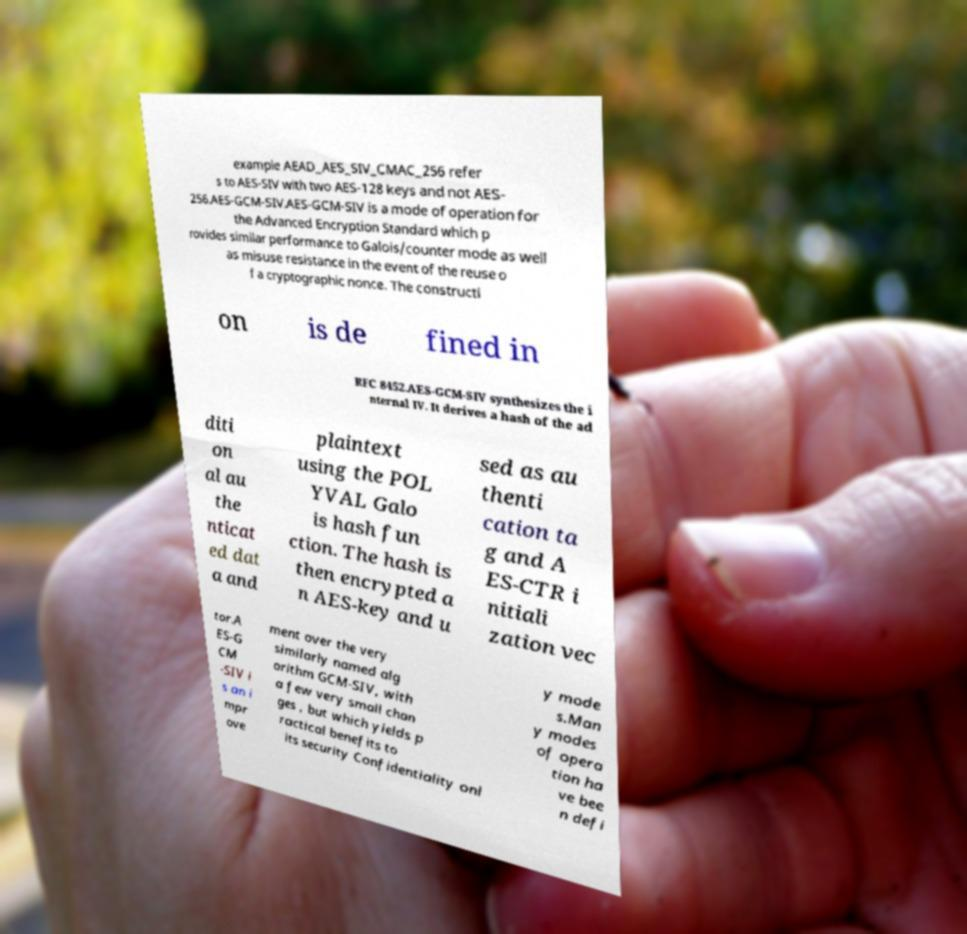Can you read and provide the text displayed in the image?This photo seems to have some interesting text. Can you extract and type it out for me? example AEAD_AES_SIV_CMAC_256 refer s to AES-SIV with two AES-128 keys and not AES- 256.AES-GCM-SIV.AES-GCM-SIV is a mode of operation for the Advanced Encryption Standard which p rovides similar performance to Galois/counter mode as well as misuse resistance in the event of the reuse o f a cryptographic nonce. The constructi on is de fined in RFC 8452.AES-GCM-SIV synthesizes the i nternal IV. It derives a hash of the ad diti on al au the nticat ed dat a and plaintext using the POL YVAL Galo is hash fun ction. The hash is then encrypted a n AES-key and u sed as au thenti cation ta g and A ES-CTR i nitiali zation vec tor.A ES-G CM -SIV i s an i mpr ove ment over the very similarly named alg orithm GCM-SIV, with a few very small chan ges , but which yields p ractical benefits to its security Confidentiality onl y mode s.Man y modes of opera tion ha ve bee n defi 